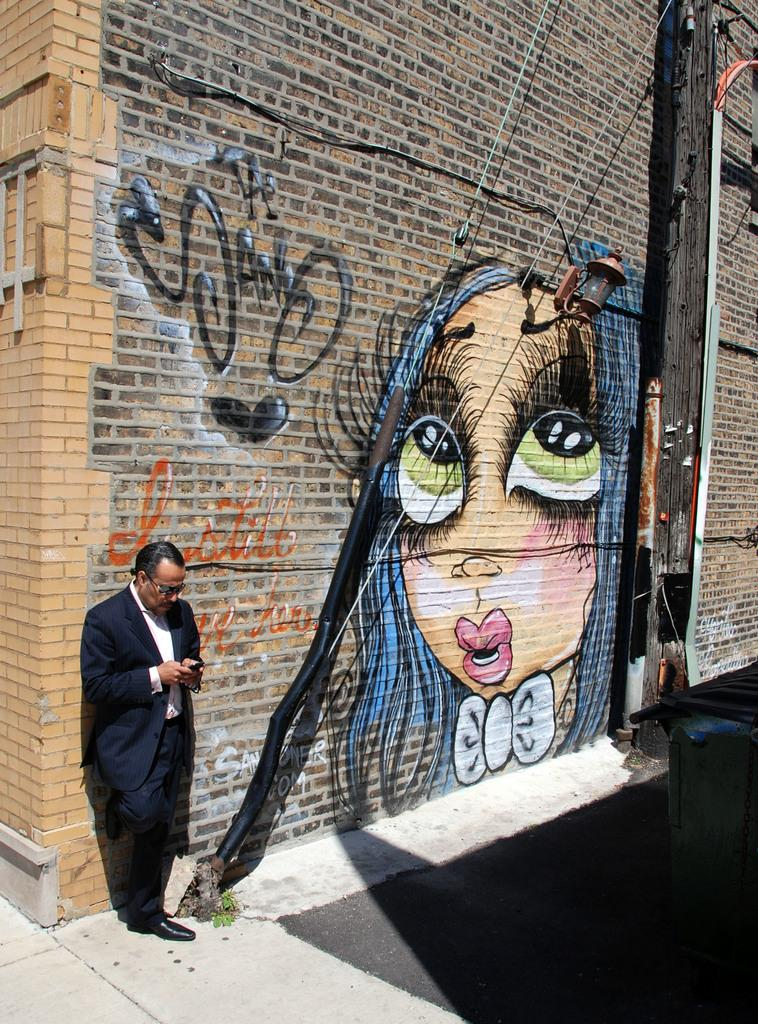What is present on the wall in the image? There is a painting on the wall in the image. What else can be seen on the wall? There is no other information provided about the wall, so we cannot answer this question definitively. Where is the man located in the image? The man is standing on the left side of the image. What is the man wearing? The man is wearing a black dress. What type of produce is the man holding in the image? There is no produce present in the image; the man is not holding anything. How many friends is the man talking to in the image? There is no information provided about friends or a conversation in the image. 